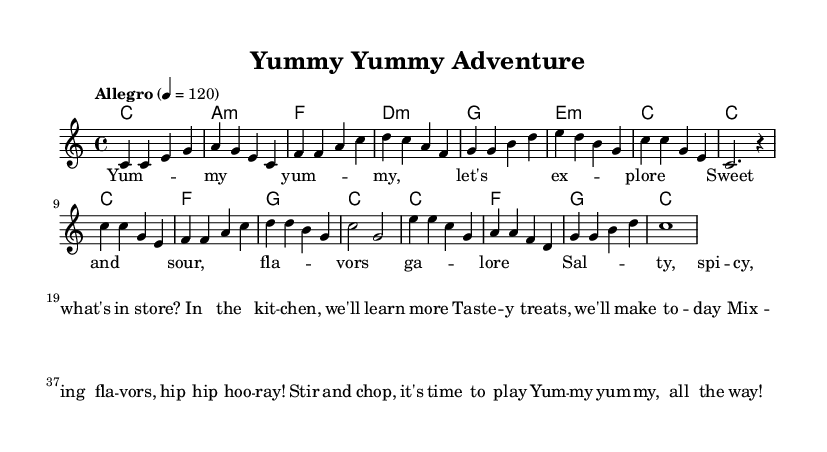What is the key signature of this music? The key signature shown is C major, which is characterized by having no sharps or flats. This is identified by looking at the key indicated at the start of the score.
Answer: C major What is the time signature of this piece? The time signature is 4/4, which indicates that there are four beats in each measure and a quarter note receives one beat. This is stated at the beginning of the score.
Answer: 4/4 What is the tempo marking given for this piece? The tempo marking provided is "Allegro" with a metronome marking of 120 beats per minute. This indicates a fast-paced tempo.
Answer: Allegro, 120 How many measures are in the verse section? The verse section consists of eight measures, which can be counted by analyzing the sections of the melody and identifying where the phrases end.
Answer: Eight What are the first two lyrics of the chorus? The first two lyrics of the chorus are "Yum my", which can be found by looking at the lyrical section corresponding to the chorus within the score.
Answer: Yum my How many chords are played in the chorus section? There are six chords played in the chorus section, as counted in the harmonic section corresponding to that part of the song.
Answer: Six What is the theme of this K-Pop song? The theme revolves around exploring different tastes and flavors in the kitchen, encouraging playful interaction with food. This is evident from the lyrics talking about making tasty treats and mixing flavors.
Answer: Exploring different tastes 